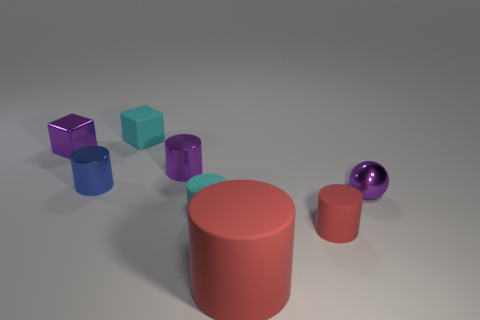Does the tiny cylinder that is to the right of the big red rubber cylinder have the same material as the tiny sphere?
Give a very brief answer. No. What material is the cyan thing that is in front of the small block in front of the tiny block that is on the right side of the small blue shiny cylinder?
Provide a succinct answer. Rubber. Is there any other thing that is the same size as the purple cylinder?
Provide a succinct answer. Yes. What number of matte objects are balls or big cyan objects?
Provide a succinct answer. 0. Are any cubes visible?
Ensure brevity in your answer.  Yes. What color is the matte object behind the metallic cylinder left of the tiny matte cube?
Keep it short and to the point. Cyan. How many other objects are the same color as the big matte cylinder?
Give a very brief answer. 1. How many objects are either big rubber things or cylinders that are in front of the tiny cyan cylinder?
Make the answer very short. 2. What color is the small cylinder behind the blue metal thing?
Your answer should be compact. Purple. The large object has what shape?
Offer a very short reply. Cylinder. 